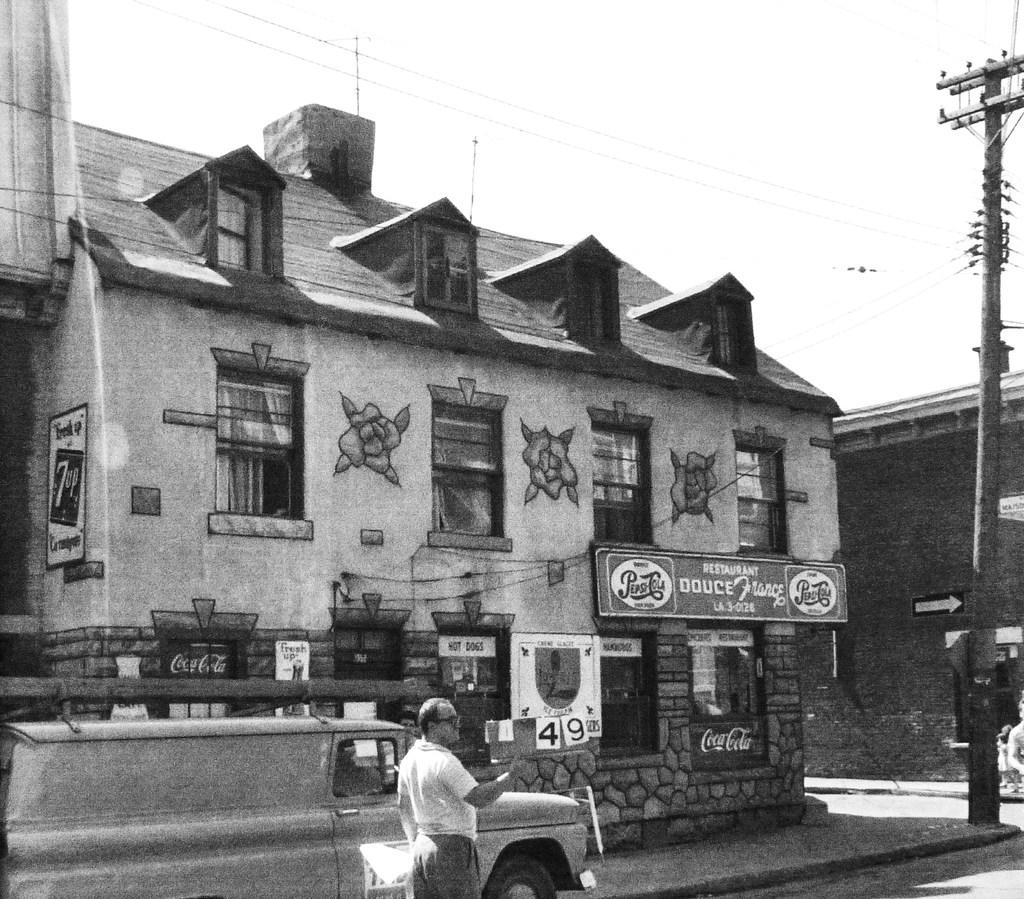What type of structure is present in the image? There is a building in the image. What feature can be seen on the building? The building has windows. What additional object is present in the image? There is a banner in the image. What mode of transportation is visible in the image? There is a truck in the image. Who is present in the image? A man is standing in the image. How many boys are playing in the background of the image? There is no mention of boys or any play activity in the image. The image features a building, windows, a banner, a truck, and a man. 